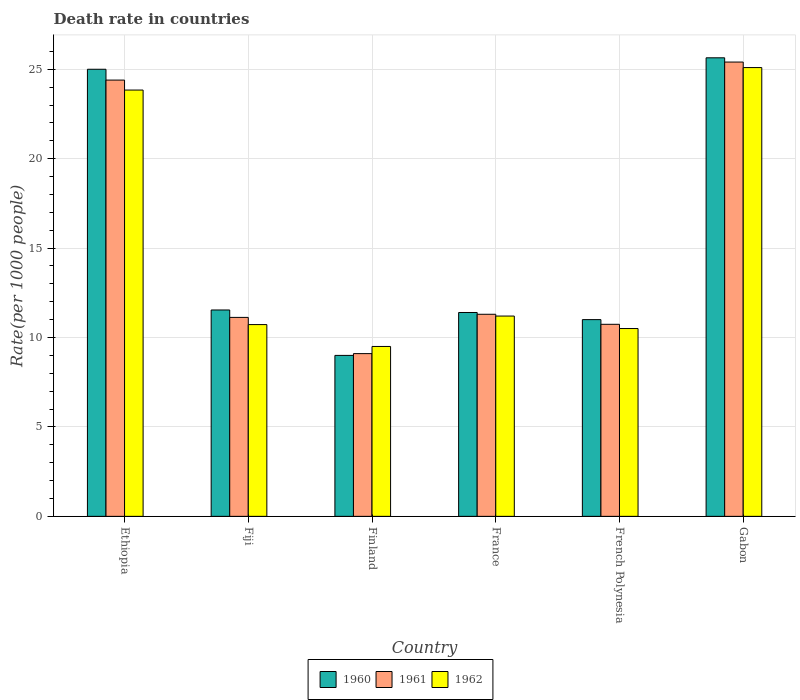Are the number of bars per tick equal to the number of legend labels?
Ensure brevity in your answer.  Yes. What is the label of the 2nd group of bars from the left?
Ensure brevity in your answer.  Fiji. In how many cases, is the number of bars for a given country not equal to the number of legend labels?
Make the answer very short. 0. What is the death rate in 1960 in Ethiopia?
Offer a terse response. 25. Across all countries, what is the maximum death rate in 1960?
Keep it short and to the point. 25.64. Across all countries, what is the minimum death rate in 1962?
Make the answer very short. 9.5. In which country was the death rate in 1961 maximum?
Your answer should be very brief. Gabon. What is the total death rate in 1960 in the graph?
Your answer should be very brief. 93.58. What is the difference between the death rate in 1960 in Ethiopia and that in Fiji?
Your response must be concise. 13.46. What is the difference between the death rate in 1960 in French Polynesia and the death rate in 1961 in Finland?
Your answer should be compact. 1.9. What is the average death rate in 1961 per country?
Provide a short and direct response. 15.34. What is the difference between the death rate of/in 1962 and death rate of/in 1961 in French Polynesia?
Keep it short and to the point. -0.24. In how many countries, is the death rate in 1961 greater than 16?
Make the answer very short. 2. What is the ratio of the death rate in 1960 in Fiji to that in France?
Keep it short and to the point. 1.01. Is the difference between the death rate in 1962 in Fiji and Finland greater than the difference between the death rate in 1961 in Fiji and Finland?
Your answer should be very brief. No. What is the difference between the highest and the second highest death rate in 1962?
Keep it short and to the point. 13.9. What is the difference between the highest and the lowest death rate in 1960?
Your answer should be compact. 16.64. Are all the bars in the graph horizontal?
Make the answer very short. No. What is the difference between two consecutive major ticks on the Y-axis?
Make the answer very short. 5. Does the graph contain grids?
Offer a terse response. Yes. How are the legend labels stacked?
Provide a short and direct response. Horizontal. What is the title of the graph?
Provide a short and direct response. Death rate in countries. Does "1980" appear as one of the legend labels in the graph?
Your answer should be compact. No. What is the label or title of the X-axis?
Ensure brevity in your answer.  Country. What is the label or title of the Y-axis?
Make the answer very short. Rate(per 1000 people). What is the Rate(per 1000 people) of 1960 in Ethiopia?
Your answer should be compact. 25. What is the Rate(per 1000 people) in 1961 in Ethiopia?
Offer a terse response. 24.4. What is the Rate(per 1000 people) in 1962 in Ethiopia?
Your answer should be very brief. 23.84. What is the Rate(per 1000 people) of 1960 in Fiji?
Your response must be concise. 11.54. What is the Rate(per 1000 people) in 1961 in Fiji?
Your answer should be very brief. 11.12. What is the Rate(per 1000 people) of 1962 in Fiji?
Make the answer very short. 10.72. What is the Rate(per 1000 people) of 1962 in Finland?
Offer a terse response. 9.5. What is the Rate(per 1000 people) of 1961 in France?
Offer a terse response. 11.3. What is the Rate(per 1000 people) of 1962 in France?
Ensure brevity in your answer.  11.2. What is the Rate(per 1000 people) of 1960 in French Polynesia?
Keep it short and to the point. 11. What is the Rate(per 1000 people) in 1961 in French Polynesia?
Give a very brief answer. 10.74. What is the Rate(per 1000 people) of 1962 in French Polynesia?
Ensure brevity in your answer.  10.5. What is the Rate(per 1000 people) in 1960 in Gabon?
Provide a short and direct response. 25.64. What is the Rate(per 1000 people) in 1961 in Gabon?
Provide a short and direct response. 25.4. What is the Rate(per 1000 people) in 1962 in Gabon?
Offer a terse response. 25.1. Across all countries, what is the maximum Rate(per 1000 people) in 1960?
Provide a succinct answer. 25.64. Across all countries, what is the maximum Rate(per 1000 people) in 1961?
Your answer should be compact. 25.4. Across all countries, what is the maximum Rate(per 1000 people) of 1962?
Give a very brief answer. 25.1. Across all countries, what is the minimum Rate(per 1000 people) in 1960?
Provide a succinct answer. 9. Across all countries, what is the minimum Rate(per 1000 people) in 1961?
Provide a succinct answer. 9.1. Across all countries, what is the minimum Rate(per 1000 people) in 1962?
Offer a terse response. 9.5. What is the total Rate(per 1000 people) in 1960 in the graph?
Your answer should be compact. 93.58. What is the total Rate(per 1000 people) in 1961 in the graph?
Your answer should be very brief. 92.06. What is the total Rate(per 1000 people) of 1962 in the graph?
Provide a succinct answer. 90.86. What is the difference between the Rate(per 1000 people) in 1960 in Ethiopia and that in Fiji?
Your answer should be very brief. 13.46. What is the difference between the Rate(per 1000 people) of 1961 in Ethiopia and that in Fiji?
Give a very brief answer. 13.27. What is the difference between the Rate(per 1000 people) in 1962 in Ethiopia and that in Fiji?
Keep it short and to the point. 13.12. What is the difference between the Rate(per 1000 people) in 1960 in Ethiopia and that in Finland?
Keep it short and to the point. 16. What is the difference between the Rate(per 1000 people) of 1961 in Ethiopia and that in Finland?
Offer a terse response. 15.3. What is the difference between the Rate(per 1000 people) in 1962 in Ethiopia and that in Finland?
Your answer should be compact. 14.34. What is the difference between the Rate(per 1000 people) of 1960 in Ethiopia and that in France?
Ensure brevity in your answer.  13.6. What is the difference between the Rate(per 1000 people) in 1961 in Ethiopia and that in France?
Provide a short and direct response. 13.1. What is the difference between the Rate(per 1000 people) of 1962 in Ethiopia and that in France?
Offer a very short reply. 12.64. What is the difference between the Rate(per 1000 people) in 1960 in Ethiopia and that in French Polynesia?
Give a very brief answer. 14. What is the difference between the Rate(per 1000 people) in 1961 in Ethiopia and that in French Polynesia?
Make the answer very short. 13.66. What is the difference between the Rate(per 1000 people) in 1962 in Ethiopia and that in French Polynesia?
Ensure brevity in your answer.  13.34. What is the difference between the Rate(per 1000 people) of 1960 in Ethiopia and that in Gabon?
Provide a succinct answer. -0.64. What is the difference between the Rate(per 1000 people) of 1961 in Ethiopia and that in Gabon?
Provide a short and direct response. -1.01. What is the difference between the Rate(per 1000 people) in 1962 in Ethiopia and that in Gabon?
Keep it short and to the point. -1.26. What is the difference between the Rate(per 1000 people) in 1960 in Fiji and that in Finland?
Give a very brief answer. 2.54. What is the difference between the Rate(per 1000 people) of 1961 in Fiji and that in Finland?
Keep it short and to the point. 2.02. What is the difference between the Rate(per 1000 people) in 1962 in Fiji and that in Finland?
Give a very brief answer. 1.22. What is the difference between the Rate(per 1000 people) in 1960 in Fiji and that in France?
Give a very brief answer. 0.14. What is the difference between the Rate(per 1000 people) of 1961 in Fiji and that in France?
Make the answer very short. -0.17. What is the difference between the Rate(per 1000 people) of 1962 in Fiji and that in France?
Your response must be concise. -0.48. What is the difference between the Rate(per 1000 people) in 1960 in Fiji and that in French Polynesia?
Keep it short and to the point. 0.54. What is the difference between the Rate(per 1000 people) of 1961 in Fiji and that in French Polynesia?
Make the answer very short. 0.39. What is the difference between the Rate(per 1000 people) of 1962 in Fiji and that in French Polynesia?
Make the answer very short. 0.22. What is the difference between the Rate(per 1000 people) of 1960 in Fiji and that in Gabon?
Give a very brief answer. -14.1. What is the difference between the Rate(per 1000 people) in 1961 in Fiji and that in Gabon?
Your response must be concise. -14.28. What is the difference between the Rate(per 1000 people) of 1962 in Fiji and that in Gabon?
Your answer should be very brief. -14.37. What is the difference between the Rate(per 1000 people) of 1962 in Finland and that in France?
Your answer should be very brief. -1.7. What is the difference between the Rate(per 1000 people) of 1960 in Finland and that in French Polynesia?
Your answer should be very brief. -2. What is the difference between the Rate(per 1000 people) of 1961 in Finland and that in French Polynesia?
Keep it short and to the point. -1.64. What is the difference between the Rate(per 1000 people) of 1962 in Finland and that in French Polynesia?
Offer a terse response. -1. What is the difference between the Rate(per 1000 people) of 1960 in Finland and that in Gabon?
Offer a terse response. -16.64. What is the difference between the Rate(per 1000 people) of 1961 in Finland and that in Gabon?
Give a very brief answer. -16.3. What is the difference between the Rate(per 1000 people) in 1962 in Finland and that in Gabon?
Keep it short and to the point. -15.6. What is the difference between the Rate(per 1000 people) in 1960 in France and that in French Polynesia?
Your answer should be compact. 0.4. What is the difference between the Rate(per 1000 people) in 1961 in France and that in French Polynesia?
Provide a short and direct response. 0.56. What is the difference between the Rate(per 1000 people) of 1962 in France and that in French Polynesia?
Your answer should be very brief. 0.7. What is the difference between the Rate(per 1000 people) of 1960 in France and that in Gabon?
Provide a succinct answer. -14.24. What is the difference between the Rate(per 1000 people) of 1961 in France and that in Gabon?
Your answer should be very brief. -14.1. What is the difference between the Rate(per 1000 people) of 1962 in France and that in Gabon?
Provide a succinct answer. -13.9. What is the difference between the Rate(per 1000 people) in 1960 in French Polynesia and that in Gabon?
Give a very brief answer. -14.64. What is the difference between the Rate(per 1000 people) in 1961 in French Polynesia and that in Gabon?
Ensure brevity in your answer.  -14.66. What is the difference between the Rate(per 1000 people) of 1962 in French Polynesia and that in Gabon?
Offer a terse response. -14.59. What is the difference between the Rate(per 1000 people) of 1960 in Ethiopia and the Rate(per 1000 people) of 1961 in Fiji?
Your response must be concise. 13.88. What is the difference between the Rate(per 1000 people) in 1960 in Ethiopia and the Rate(per 1000 people) in 1962 in Fiji?
Make the answer very short. 14.28. What is the difference between the Rate(per 1000 people) in 1961 in Ethiopia and the Rate(per 1000 people) in 1962 in Fiji?
Offer a very short reply. 13.67. What is the difference between the Rate(per 1000 people) of 1960 in Ethiopia and the Rate(per 1000 people) of 1961 in Finland?
Provide a short and direct response. 15.9. What is the difference between the Rate(per 1000 people) of 1960 in Ethiopia and the Rate(per 1000 people) of 1962 in Finland?
Your answer should be very brief. 15.5. What is the difference between the Rate(per 1000 people) in 1961 in Ethiopia and the Rate(per 1000 people) in 1962 in Finland?
Your response must be concise. 14.9. What is the difference between the Rate(per 1000 people) of 1960 in Ethiopia and the Rate(per 1000 people) of 1961 in France?
Provide a short and direct response. 13.7. What is the difference between the Rate(per 1000 people) of 1960 in Ethiopia and the Rate(per 1000 people) of 1962 in France?
Make the answer very short. 13.8. What is the difference between the Rate(per 1000 people) of 1961 in Ethiopia and the Rate(per 1000 people) of 1962 in France?
Offer a terse response. 13.2. What is the difference between the Rate(per 1000 people) of 1960 in Ethiopia and the Rate(per 1000 people) of 1961 in French Polynesia?
Ensure brevity in your answer.  14.26. What is the difference between the Rate(per 1000 people) of 1960 in Ethiopia and the Rate(per 1000 people) of 1962 in French Polynesia?
Keep it short and to the point. 14.5. What is the difference between the Rate(per 1000 people) in 1961 in Ethiopia and the Rate(per 1000 people) in 1962 in French Polynesia?
Give a very brief answer. 13.89. What is the difference between the Rate(per 1000 people) in 1960 in Ethiopia and the Rate(per 1000 people) in 1961 in Gabon?
Keep it short and to the point. -0.4. What is the difference between the Rate(per 1000 people) in 1960 in Ethiopia and the Rate(per 1000 people) in 1962 in Gabon?
Your response must be concise. -0.1. What is the difference between the Rate(per 1000 people) in 1960 in Fiji and the Rate(per 1000 people) in 1961 in Finland?
Keep it short and to the point. 2.44. What is the difference between the Rate(per 1000 people) in 1960 in Fiji and the Rate(per 1000 people) in 1962 in Finland?
Keep it short and to the point. 2.04. What is the difference between the Rate(per 1000 people) in 1961 in Fiji and the Rate(per 1000 people) in 1962 in Finland?
Offer a terse response. 1.62. What is the difference between the Rate(per 1000 people) in 1960 in Fiji and the Rate(per 1000 people) in 1961 in France?
Your response must be concise. 0.24. What is the difference between the Rate(per 1000 people) in 1960 in Fiji and the Rate(per 1000 people) in 1962 in France?
Ensure brevity in your answer.  0.34. What is the difference between the Rate(per 1000 people) in 1961 in Fiji and the Rate(per 1000 people) in 1962 in France?
Your response must be concise. -0.07. What is the difference between the Rate(per 1000 people) in 1960 in Fiji and the Rate(per 1000 people) in 1961 in French Polynesia?
Give a very brief answer. 0.8. What is the difference between the Rate(per 1000 people) in 1960 in Fiji and the Rate(per 1000 people) in 1962 in French Polynesia?
Keep it short and to the point. 1.04. What is the difference between the Rate(per 1000 people) of 1961 in Fiji and the Rate(per 1000 people) of 1962 in French Polynesia?
Provide a succinct answer. 0.62. What is the difference between the Rate(per 1000 people) of 1960 in Fiji and the Rate(per 1000 people) of 1961 in Gabon?
Give a very brief answer. -13.86. What is the difference between the Rate(per 1000 people) of 1960 in Fiji and the Rate(per 1000 people) of 1962 in Gabon?
Offer a terse response. -13.56. What is the difference between the Rate(per 1000 people) in 1961 in Fiji and the Rate(per 1000 people) in 1962 in Gabon?
Your response must be concise. -13.97. What is the difference between the Rate(per 1000 people) in 1961 in Finland and the Rate(per 1000 people) in 1962 in France?
Keep it short and to the point. -2.1. What is the difference between the Rate(per 1000 people) in 1960 in Finland and the Rate(per 1000 people) in 1961 in French Polynesia?
Make the answer very short. -1.74. What is the difference between the Rate(per 1000 people) of 1960 in Finland and the Rate(per 1000 people) of 1962 in French Polynesia?
Offer a terse response. -1.5. What is the difference between the Rate(per 1000 people) of 1961 in Finland and the Rate(per 1000 people) of 1962 in French Polynesia?
Offer a very short reply. -1.4. What is the difference between the Rate(per 1000 people) in 1960 in Finland and the Rate(per 1000 people) in 1961 in Gabon?
Give a very brief answer. -16.4. What is the difference between the Rate(per 1000 people) in 1960 in Finland and the Rate(per 1000 people) in 1962 in Gabon?
Your answer should be very brief. -16.1. What is the difference between the Rate(per 1000 people) in 1961 in Finland and the Rate(per 1000 people) in 1962 in Gabon?
Keep it short and to the point. -16. What is the difference between the Rate(per 1000 people) of 1960 in France and the Rate(per 1000 people) of 1961 in French Polynesia?
Provide a succinct answer. 0.66. What is the difference between the Rate(per 1000 people) of 1960 in France and the Rate(per 1000 people) of 1962 in French Polynesia?
Make the answer very short. 0.9. What is the difference between the Rate(per 1000 people) in 1961 in France and the Rate(per 1000 people) in 1962 in French Polynesia?
Your answer should be compact. 0.8. What is the difference between the Rate(per 1000 people) in 1960 in France and the Rate(per 1000 people) in 1961 in Gabon?
Offer a terse response. -14. What is the difference between the Rate(per 1000 people) of 1960 in France and the Rate(per 1000 people) of 1962 in Gabon?
Offer a terse response. -13.7. What is the difference between the Rate(per 1000 people) in 1961 in France and the Rate(per 1000 people) in 1962 in Gabon?
Provide a succinct answer. -13.8. What is the difference between the Rate(per 1000 people) in 1960 in French Polynesia and the Rate(per 1000 people) in 1961 in Gabon?
Your answer should be very brief. -14.4. What is the difference between the Rate(per 1000 people) in 1960 in French Polynesia and the Rate(per 1000 people) in 1962 in Gabon?
Provide a short and direct response. -14.1. What is the difference between the Rate(per 1000 people) in 1961 in French Polynesia and the Rate(per 1000 people) in 1962 in Gabon?
Offer a terse response. -14.36. What is the average Rate(per 1000 people) of 1960 per country?
Ensure brevity in your answer.  15.6. What is the average Rate(per 1000 people) in 1961 per country?
Provide a short and direct response. 15.34. What is the average Rate(per 1000 people) of 1962 per country?
Your answer should be very brief. 15.14. What is the difference between the Rate(per 1000 people) in 1960 and Rate(per 1000 people) in 1961 in Ethiopia?
Your answer should be compact. 0.6. What is the difference between the Rate(per 1000 people) of 1960 and Rate(per 1000 people) of 1962 in Ethiopia?
Give a very brief answer. 1.16. What is the difference between the Rate(per 1000 people) in 1961 and Rate(per 1000 people) in 1962 in Ethiopia?
Offer a very short reply. 0.56. What is the difference between the Rate(per 1000 people) in 1960 and Rate(per 1000 people) in 1961 in Fiji?
Provide a short and direct response. 0.41. What is the difference between the Rate(per 1000 people) of 1960 and Rate(per 1000 people) of 1962 in Fiji?
Your answer should be compact. 0.82. What is the difference between the Rate(per 1000 people) of 1961 and Rate(per 1000 people) of 1962 in Fiji?
Provide a short and direct response. 0.4. What is the difference between the Rate(per 1000 people) in 1960 and Rate(per 1000 people) in 1962 in Finland?
Provide a succinct answer. -0.5. What is the difference between the Rate(per 1000 people) of 1960 and Rate(per 1000 people) of 1961 in France?
Give a very brief answer. 0.1. What is the difference between the Rate(per 1000 people) in 1960 and Rate(per 1000 people) in 1962 in France?
Give a very brief answer. 0.2. What is the difference between the Rate(per 1000 people) of 1961 and Rate(per 1000 people) of 1962 in France?
Your answer should be very brief. 0.1. What is the difference between the Rate(per 1000 people) in 1960 and Rate(per 1000 people) in 1961 in French Polynesia?
Your answer should be very brief. 0.26. What is the difference between the Rate(per 1000 people) of 1960 and Rate(per 1000 people) of 1962 in French Polynesia?
Make the answer very short. 0.5. What is the difference between the Rate(per 1000 people) of 1961 and Rate(per 1000 people) of 1962 in French Polynesia?
Keep it short and to the point. 0.24. What is the difference between the Rate(per 1000 people) of 1960 and Rate(per 1000 people) of 1961 in Gabon?
Offer a terse response. 0.24. What is the difference between the Rate(per 1000 people) in 1960 and Rate(per 1000 people) in 1962 in Gabon?
Your answer should be very brief. 0.55. What is the difference between the Rate(per 1000 people) of 1961 and Rate(per 1000 people) of 1962 in Gabon?
Your response must be concise. 0.31. What is the ratio of the Rate(per 1000 people) in 1960 in Ethiopia to that in Fiji?
Provide a short and direct response. 2.17. What is the ratio of the Rate(per 1000 people) of 1961 in Ethiopia to that in Fiji?
Offer a very short reply. 2.19. What is the ratio of the Rate(per 1000 people) of 1962 in Ethiopia to that in Fiji?
Give a very brief answer. 2.22. What is the ratio of the Rate(per 1000 people) in 1960 in Ethiopia to that in Finland?
Keep it short and to the point. 2.78. What is the ratio of the Rate(per 1000 people) in 1961 in Ethiopia to that in Finland?
Make the answer very short. 2.68. What is the ratio of the Rate(per 1000 people) in 1962 in Ethiopia to that in Finland?
Your response must be concise. 2.51. What is the ratio of the Rate(per 1000 people) of 1960 in Ethiopia to that in France?
Your answer should be very brief. 2.19. What is the ratio of the Rate(per 1000 people) in 1961 in Ethiopia to that in France?
Offer a very short reply. 2.16. What is the ratio of the Rate(per 1000 people) in 1962 in Ethiopia to that in France?
Ensure brevity in your answer.  2.13. What is the ratio of the Rate(per 1000 people) of 1960 in Ethiopia to that in French Polynesia?
Provide a short and direct response. 2.27. What is the ratio of the Rate(per 1000 people) of 1961 in Ethiopia to that in French Polynesia?
Your answer should be compact. 2.27. What is the ratio of the Rate(per 1000 people) of 1962 in Ethiopia to that in French Polynesia?
Provide a succinct answer. 2.27. What is the ratio of the Rate(per 1000 people) of 1961 in Ethiopia to that in Gabon?
Your answer should be compact. 0.96. What is the ratio of the Rate(per 1000 people) of 1962 in Ethiopia to that in Gabon?
Provide a short and direct response. 0.95. What is the ratio of the Rate(per 1000 people) in 1960 in Fiji to that in Finland?
Your answer should be compact. 1.28. What is the ratio of the Rate(per 1000 people) of 1961 in Fiji to that in Finland?
Provide a succinct answer. 1.22. What is the ratio of the Rate(per 1000 people) of 1962 in Fiji to that in Finland?
Your answer should be very brief. 1.13. What is the ratio of the Rate(per 1000 people) in 1960 in Fiji to that in France?
Your answer should be very brief. 1.01. What is the ratio of the Rate(per 1000 people) in 1961 in Fiji to that in France?
Ensure brevity in your answer.  0.98. What is the ratio of the Rate(per 1000 people) of 1962 in Fiji to that in France?
Your response must be concise. 0.96. What is the ratio of the Rate(per 1000 people) of 1960 in Fiji to that in French Polynesia?
Offer a terse response. 1.05. What is the ratio of the Rate(per 1000 people) in 1961 in Fiji to that in French Polynesia?
Your response must be concise. 1.04. What is the ratio of the Rate(per 1000 people) in 1960 in Fiji to that in Gabon?
Ensure brevity in your answer.  0.45. What is the ratio of the Rate(per 1000 people) in 1961 in Fiji to that in Gabon?
Ensure brevity in your answer.  0.44. What is the ratio of the Rate(per 1000 people) in 1962 in Fiji to that in Gabon?
Offer a very short reply. 0.43. What is the ratio of the Rate(per 1000 people) in 1960 in Finland to that in France?
Offer a very short reply. 0.79. What is the ratio of the Rate(per 1000 people) in 1961 in Finland to that in France?
Give a very brief answer. 0.81. What is the ratio of the Rate(per 1000 people) in 1962 in Finland to that in France?
Your answer should be very brief. 0.85. What is the ratio of the Rate(per 1000 people) of 1960 in Finland to that in French Polynesia?
Offer a very short reply. 0.82. What is the ratio of the Rate(per 1000 people) in 1961 in Finland to that in French Polynesia?
Make the answer very short. 0.85. What is the ratio of the Rate(per 1000 people) in 1962 in Finland to that in French Polynesia?
Provide a succinct answer. 0.9. What is the ratio of the Rate(per 1000 people) of 1960 in Finland to that in Gabon?
Provide a succinct answer. 0.35. What is the ratio of the Rate(per 1000 people) in 1961 in Finland to that in Gabon?
Your answer should be compact. 0.36. What is the ratio of the Rate(per 1000 people) of 1962 in Finland to that in Gabon?
Ensure brevity in your answer.  0.38. What is the ratio of the Rate(per 1000 people) of 1960 in France to that in French Polynesia?
Your answer should be compact. 1.04. What is the ratio of the Rate(per 1000 people) of 1961 in France to that in French Polynesia?
Keep it short and to the point. 1.05. What is the ratio of the Rate(per 1000 people) in 1962 in France to that in French Polynesia?
Your answer should be compact. 1.07. What is the ratio of the Rate(per 1000 people) of 1960 in France to that in Gabon?
Your answer should be compact. 0.44. What is the ratio of the Rate(per 1000 people) of 1961 in France to that in Gabon?
Provide a short and direct response. 0.44. What is the ratio of the Rate(per 1000 people) in 1962 in France to that in Gabon?
Offer a terse response. 0.45. What is the ratio of the Rate(per 1000 people) of 1960 in French Polynesia to that in Gabon?
Ensure brevity in your answer.  0.43. What is the ratio of the Rate(per 1000 people) of 1961 in French Polynesia to that in Gabon?
Ensure brevity in your answer.  0.42. What is the ratio of the Rate(per 1000 people) of 1962 in French Polynesia to that in Gabon?
Your response must be concise. 0.42. What is the difference between the highest and the second highest Rate(per 1000 people) in 1960?
Your answer should be compact. 0.64. What is the difference between the highest and the second highest Rate(per 1000 people) of 1962?
Offer a terse response. 1.26. What is the difference between the highest and the lowest Rate(per 1000 people) in 1960?
Your answer should be very brief. 16.64. What is the difference between the highest and the lowest Rate(per 1000 people) in 1961?
Offer a very short reply. 16.3. What is the difference between the highest and the lowest Rate(per 1000 people) of 1962?
Make the answer very short. 15.6. 